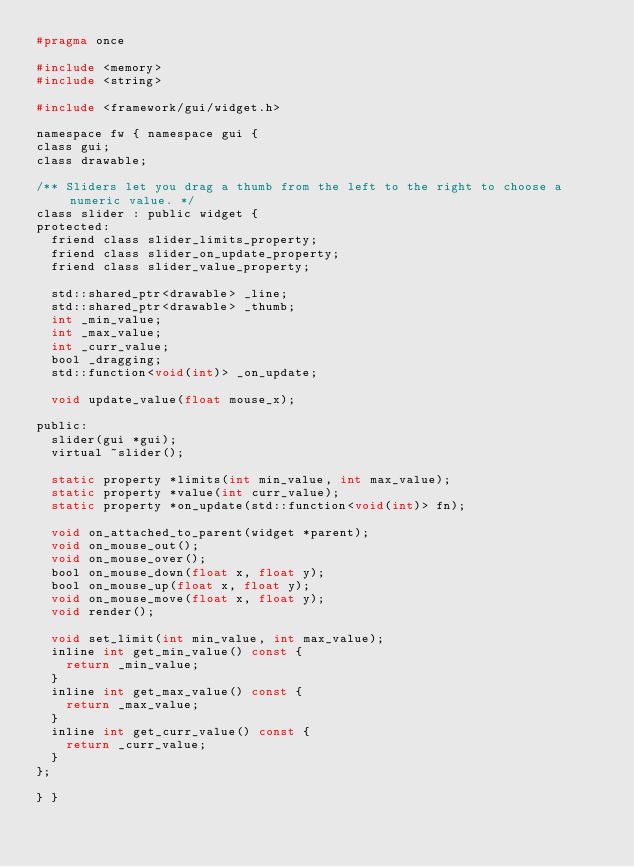<code> <loc_0><loc_0><loc_500><loc_500><_C_>#pragma once

#include <memory>
#include <string>

#include <framework/gui/widget.h>

namespace fw { namespace gui {
class gui;
class drawable;

/** Sliders let you drag a thumb from the left to the right to choose a numeric value. */
class slider : public widget {
protected:
  friend class slider_limits_property;
  friend class slider_on_update_property;
  friend class slider_value_property;

  std::shared_ptr<drawable> _line;
  std::shared_ptr<drawable> _thumb;
  int _min_value;
  int _max_value;
  int _curr_value;
  bool _dragging;
  std::function<void(int)> _on_update;

  void update_value(float mouse_x);

public:
  slider(gui *gui);
  virtual ~slider();

  static property *limits(int min_value, int max_value);
  static property *value(int curr_value);
  static property *on_update(std::function<void(int)> fn);

  void on_attached_to_parent(widget *parent);
  void on_mouse_out();
  void on_mouse_over();
  bool on_mouse_down(float x, float y);
  bool on_mouse_up(float x, float y);
  void on_mouse_move(float x, float y);
  void render();

  void set_limit(int min_value, int max_value);
  inline int get_min_value() const {
    return _min_value;
  }
  inline int get_max_value() const {
    return _max_value;
  }
  inline int get_curr_value() const {
    return _curr_value;
  }
};

} }
</code> 